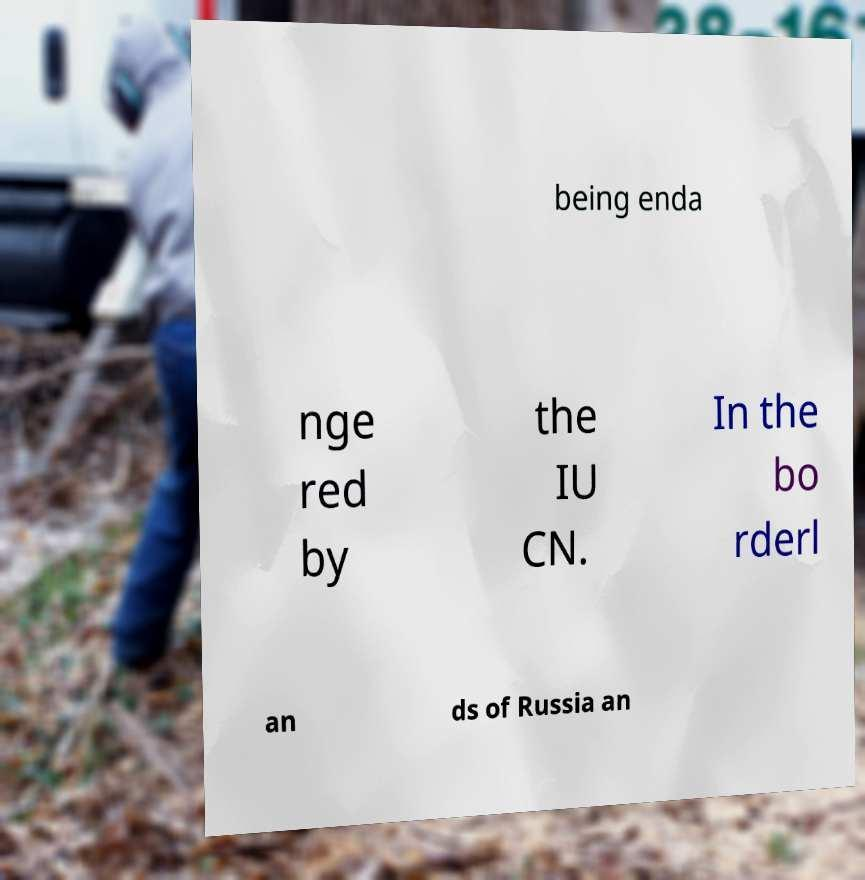Please read and relay the text visible in this image. What does it say? being enda nge red by the IU CN. In the bo rderl an ds of Russia an 